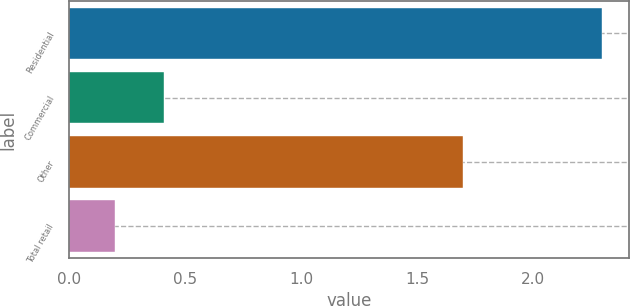Convert chart. <chart><loc_0><loc_0><loc_500><loc_500><bar_chart><fcel>Residential<fcel>Commercial<fcel>Other<fcel>Total retail<nl><fcel>2.3<fcel>0.41<fcel>1.7<fcel>0.2<nl></chart> 